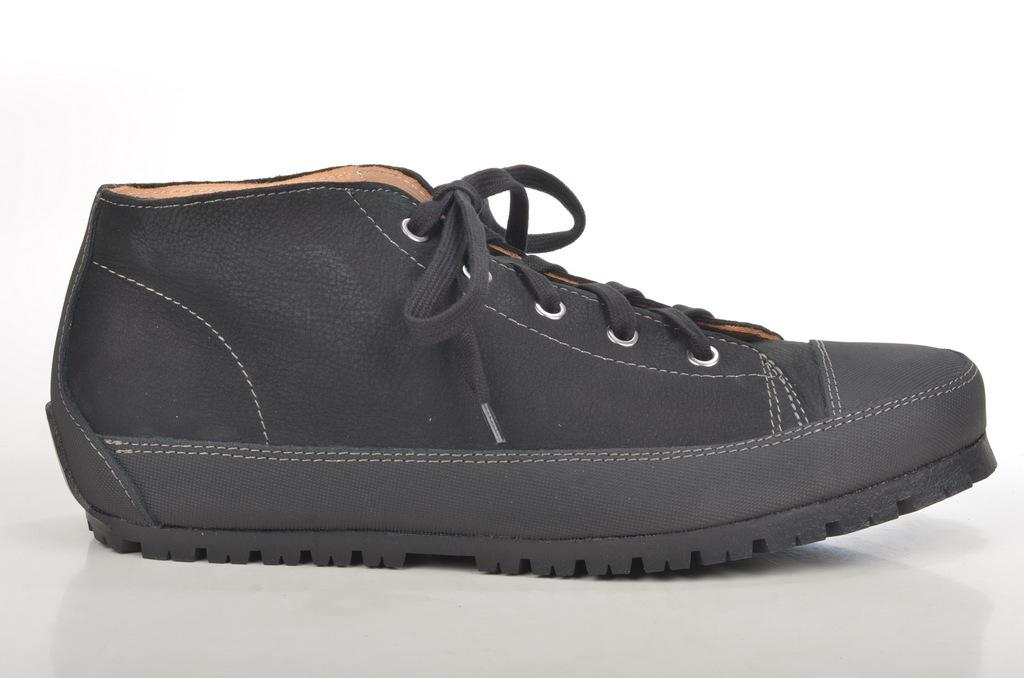What type of footwear is visible in the image? There are black color shoes in the image. What is the color of the background in the image? The background of the image is white. What type of air can be seen coming out of the shoes in the image? There is no air coming out of the shoes in the image. What type of bottle is visible next to the shoes in the image? There is no bottle present in the image. What type of system is responsible for the design of the shoes in the image? The facts provided do not give information about a system responsible for the design of the shoes. 